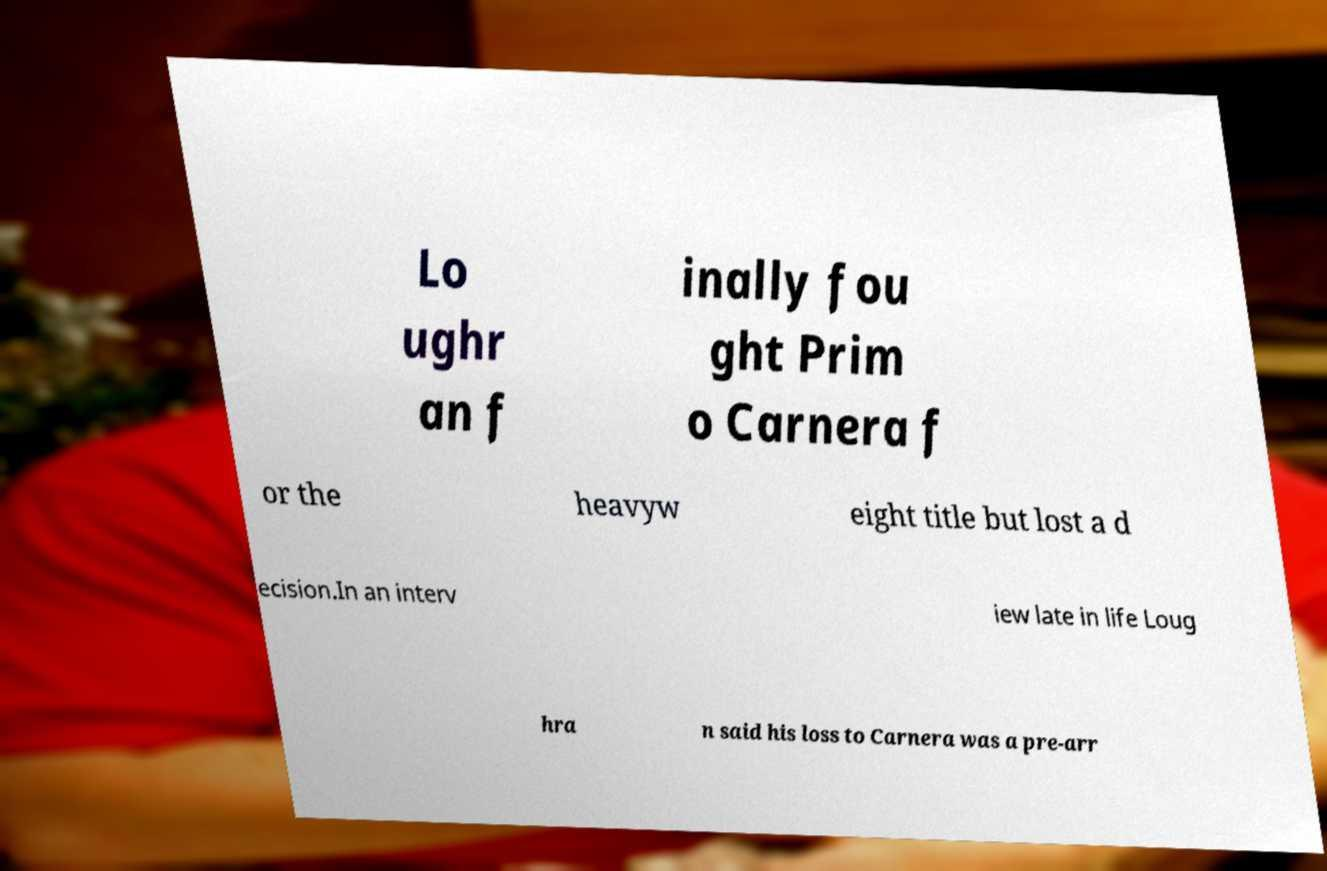Can you accurately transcribe the text from the provided image for me? Lo ughr an f inally fou ght Prim o Carnera f or the heavyw eight title but lost a d ecision.In an interv iew late in life Loug hra n said his loss to Carnera was a pre-arr 